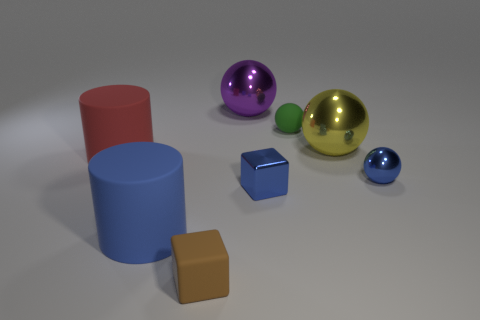Subtract all small matte balls. How many balls are left? 3 Add 1 green rubber things. How many objects exist? 9 Subtract all yellow balls. How many balls are left? 3 Subtract 1 cylinders. How many cylinders are left? 1 Subtract all blocks. How many objects are left? 6 Subtract 0 gray cubes. How many objects are left? 8 Subtract all brown balls. Subtract all yellow cylinders. How many balls are left? 4 Subtract all blue rubber cylinders. Subtract all small yellow matte cylinders. How many objects are left? 7 Add 6 blocks. How many blocks are left? 8 Add 5 big red rubber cylinders. How many big red rubber cylinders exist? 6 